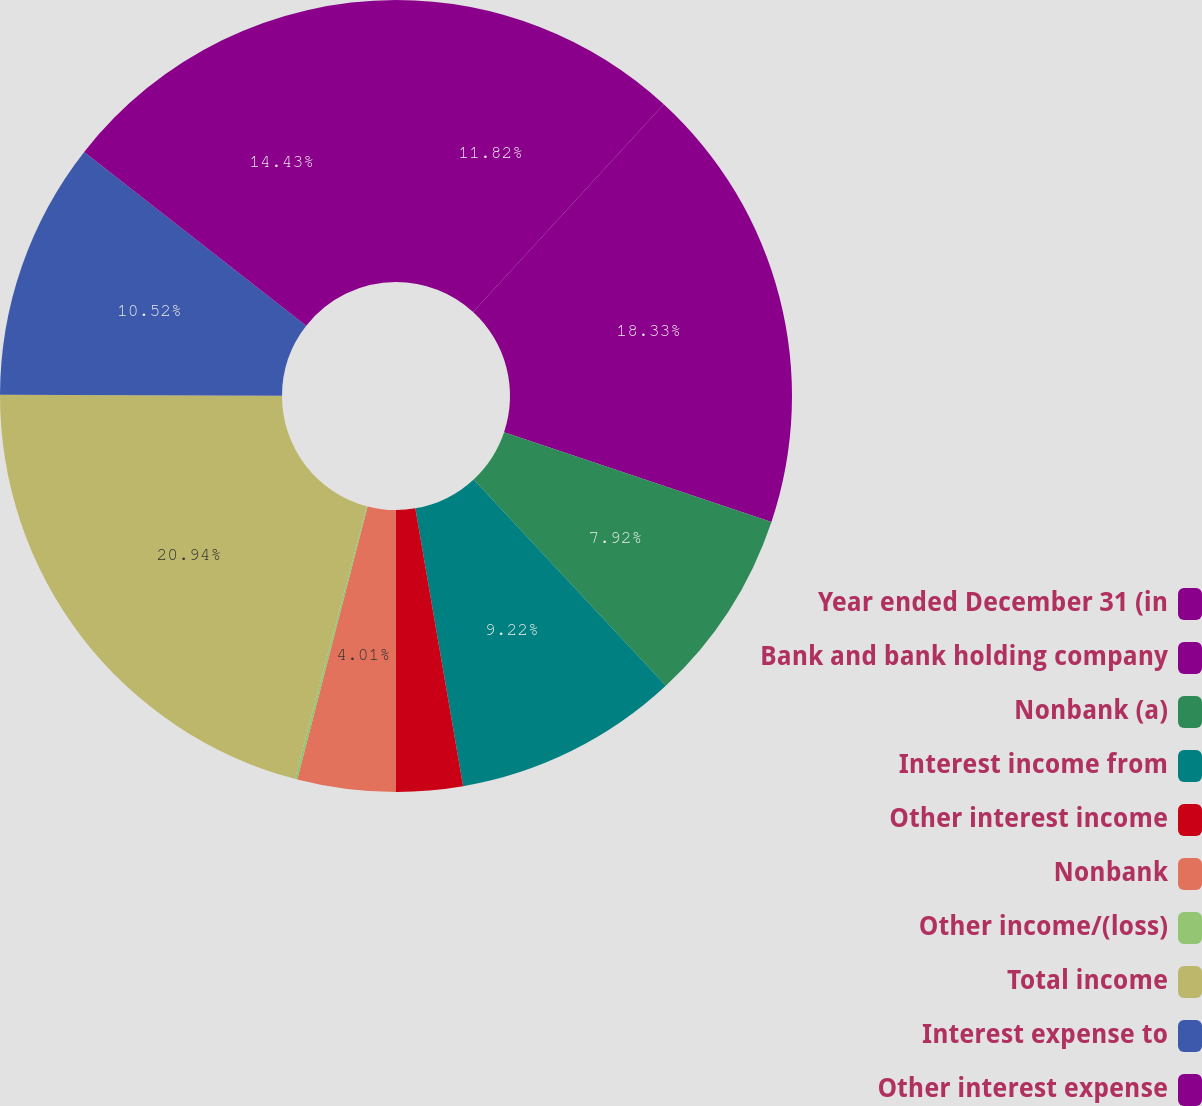<chart> <loc_0><loc_0><loc_500><loc_500><pie_chart><fcel>Year ended December 31 (in<fcel>Bank and bank holding company<fcel>Nonbank (a)<fcel>Interest income from<fcel>Other interest income<fcel>Nonbank<fcel>Other income/(loss)<fcel>Total income<fcel>Interest expense to<fcel>Other interest expense<nl><fcel>11.82%<fcel>18.33%<fcel>7.92%<fcel>9.22%<fcel>2.71%<fcel>4.01%<fcel>0.1%<fcel>20.94%<fcel>10.52%<fcel>14.43%<nl></chart> 